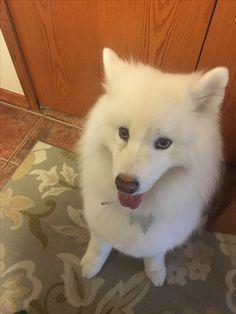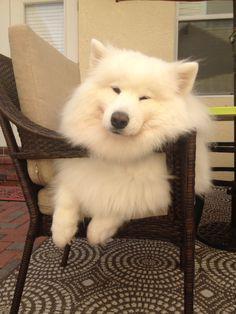The first image is the image on the left, the second image is the image on the right. Evaluate the accuracy of this statement regarding the images: "There are three dogs.". Is it true? Answer yes or no. No. 